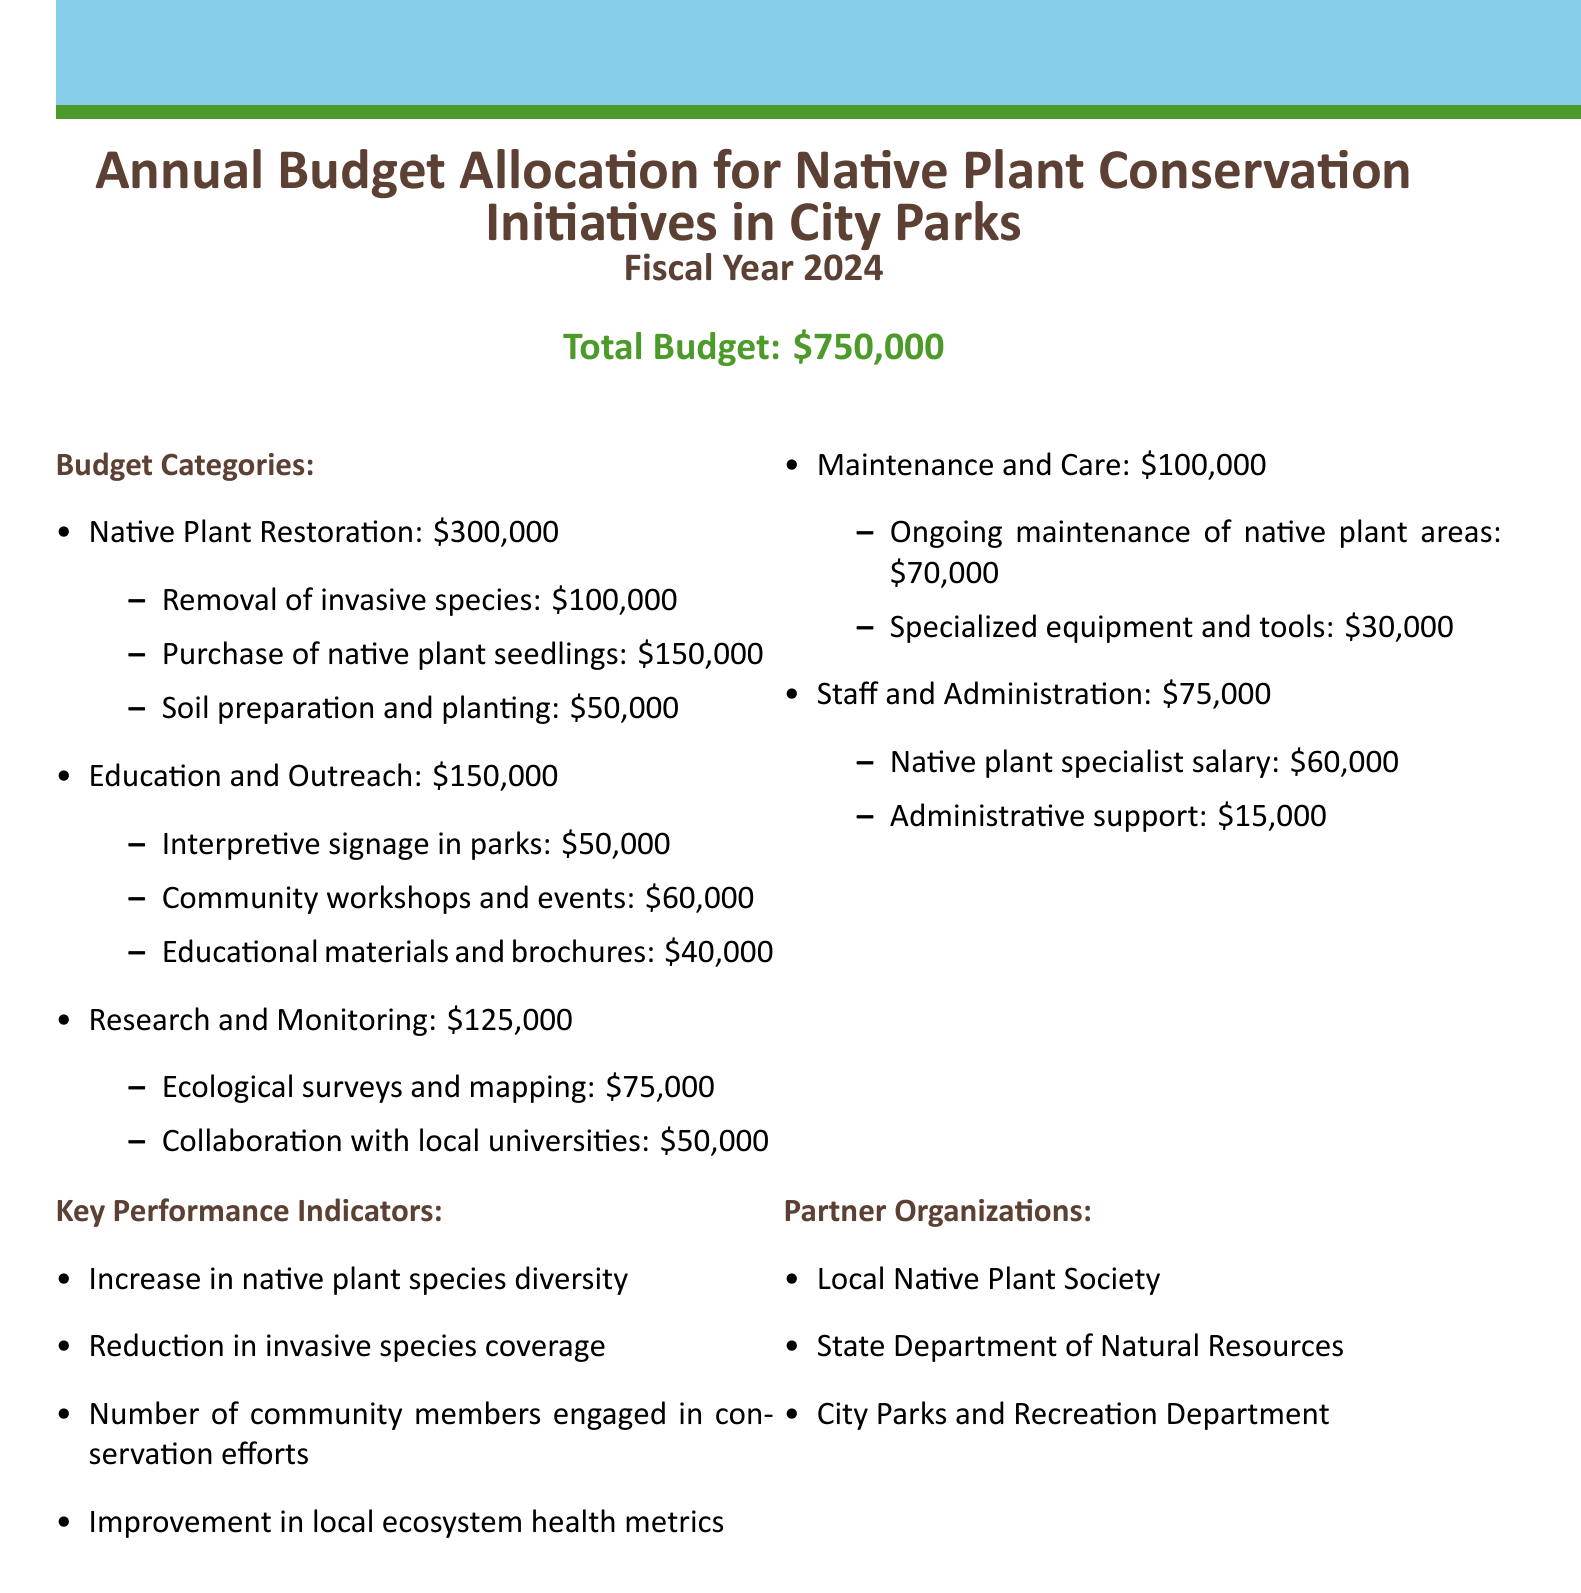What is the total budget for Fiscal Year 2024? The total budget is stated clearly in the document as the overall amount allocated for native plant conservation initiatives in city parks.
Answer: $750,000 How much is allocated for Native Plant Restoration? The document outlines the specific budget category and its allocated funding, which includes several subcategories.
Answer: $300,000 What portion of the budget is designated for Education and Outreach? This section specifies funding dedicated to educational initiatives and community engagement efforts.
Answer: $150,000 What is allocated for Removal of invasive species? The budget breakdown includes specific amounts for different activities involved in Native Plant Restoration.
Answer: $100,000 How many partner organizations are listed in the document? The document details organizations that will collaborate on the initiatives, which can be counted for the total.
Answer: 3 What is the salary for the Native plant specialist? The details around staff costs are provided in the budget document, showing clear salary allocations.
Answer: $60,000 Which category has the highest allocation of funds? By examining the budget categories and their respective amounts, we can determine the category that receives the most funding.
Answer: Native Plant Restoration What key performance indicator relates to community engagement? The document specifies various performance indicators, some of which focus on community involvement in conservation activities.
Answer: Number of community members engaged in conservation efforts What is included in the Maintenance and Care budget item? The document details ongoing costs related to care and maintenance of native plant areas, breaking it down into activities funded.
Answer: Ongoing maintenance of native plant areas and specialized equipment and tools 